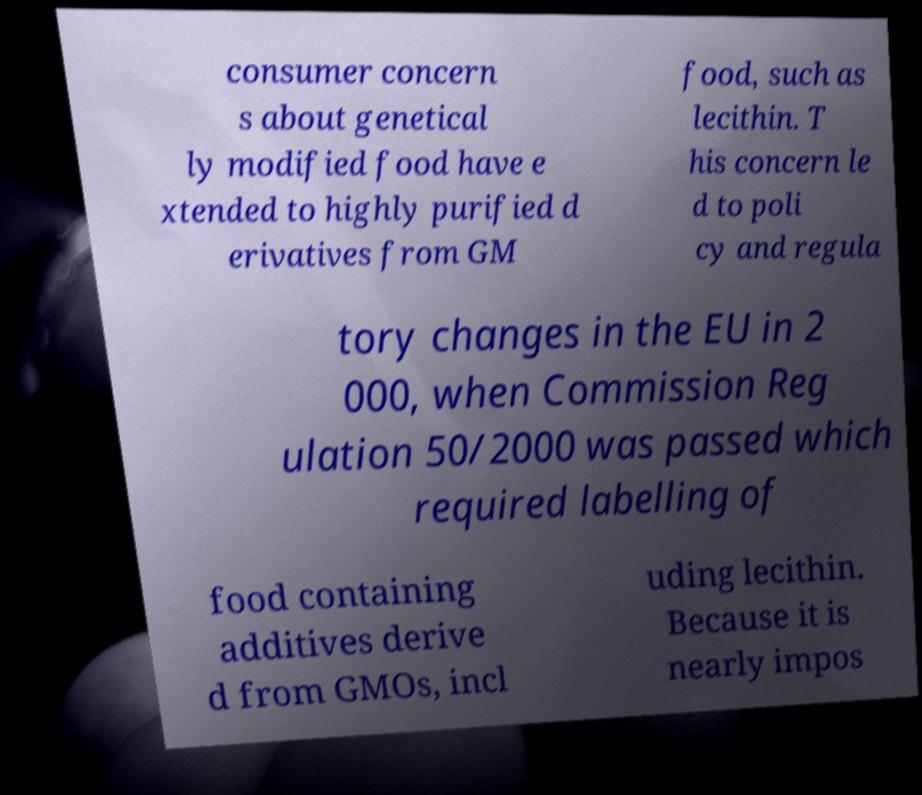I need the written content from this picture converted into text. Can you do that? consumer concern s about genetical ly modified food have e xtended to highly purified d erivatives from GM food, such as lecithin. T his concern le d to poli cy and regula tory changes in the EU in 2 000, when Commission Reg ulation 50/2000 was passed which required labelling of food containing additives derive d from GMOs, incl uding lecithin. Because it is nearly impos 